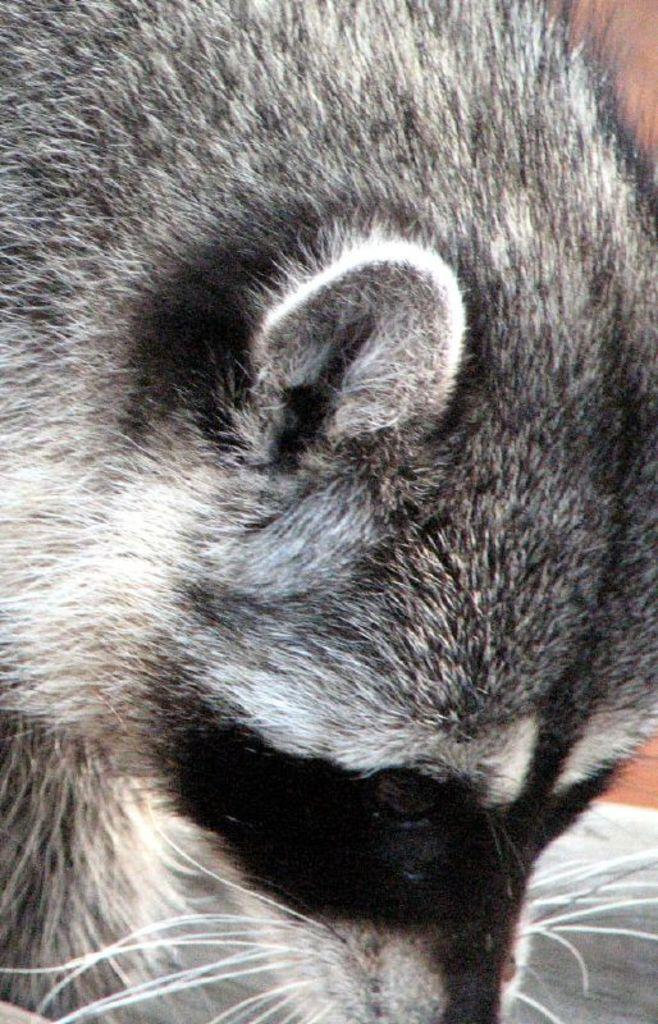What type of creature is present in the image? There is an animal in the image. Can you describe the color pattern of the animal? The animal is white and black in color. What type of machine is being used to cover the animal's elbow in the image? There is no machine or elbow present in the image; it features an animal with a white and black color pattern. 